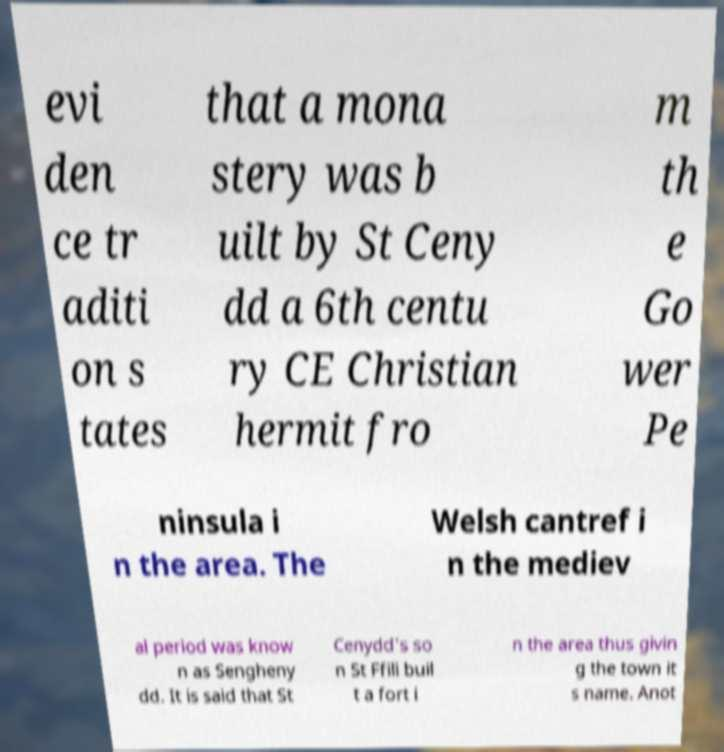Please read and relay the text visible in this image. What does it say? evi den ce tr aditi on s tates that a mona stery was b uilt by St Ceny dd a 6th centu ry CE Christian hermit fro m th e Go wer Pe ninsula i n the area. The Welsh cantref i n the mediev al period was know n as Sengheny dd. It is said that St Cenydd's so n St Ffili buil t a fort i n the area thus givin g the town it s name. Anot 